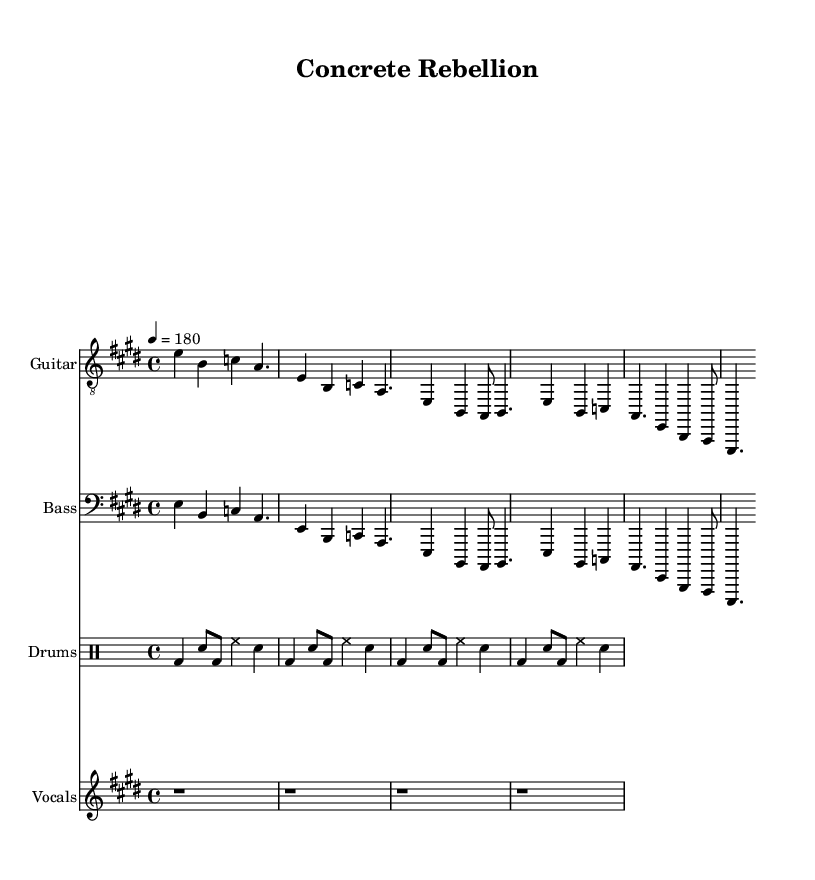What is the key signature of this music? The key signature is E major, which has four sharps: F#, C#, G#, and D#. This can be identified by looking at the key signature notated at the beginning of the staff.
Answer: E major What is the time signature of this music? The time signature is 4/4, which can be determined by looking at the denominator and numerator in the time notation at the beginning of the score. The first number (4) indicates four beats per measure, while the second number (4) indicates that a quarter note gets one beat.
Answer: 4/4 What is the tempo marking for this piece? The tempo marking is 180, as indicated in the tempo notation at the beginning of the score, where it says "4 = 180". This means the beats per minute are set to 180.
Answer: 180 How many distinct sections does the song have? The song has three sections: an Intro, a Verse, and a Chorus. Each section can be identified by the different notations and lyrics provided under the guitar, bass, and vocal parts.
Answer: Three What type of percussion instruments are indicated in the music? The percussion instruments indicated in this score include a bass drum (bd), snare drum (sn), and hi-hat (hh). These can be seen in the drum notations, which use standard abbreviations for drum components.
Answer: Bass drum, snare drum, hi-hat What is the main theme of the lyrics? The main theme revolves around rebellion and freedom in skateboarding culture, as suggested by phrases like "Wheels on concrete" and "Skate or die." This can be inferred from the content of the lyrics presented, which emphasize themes of breaking free and resistance.
Answer: Rebellion and freedom 